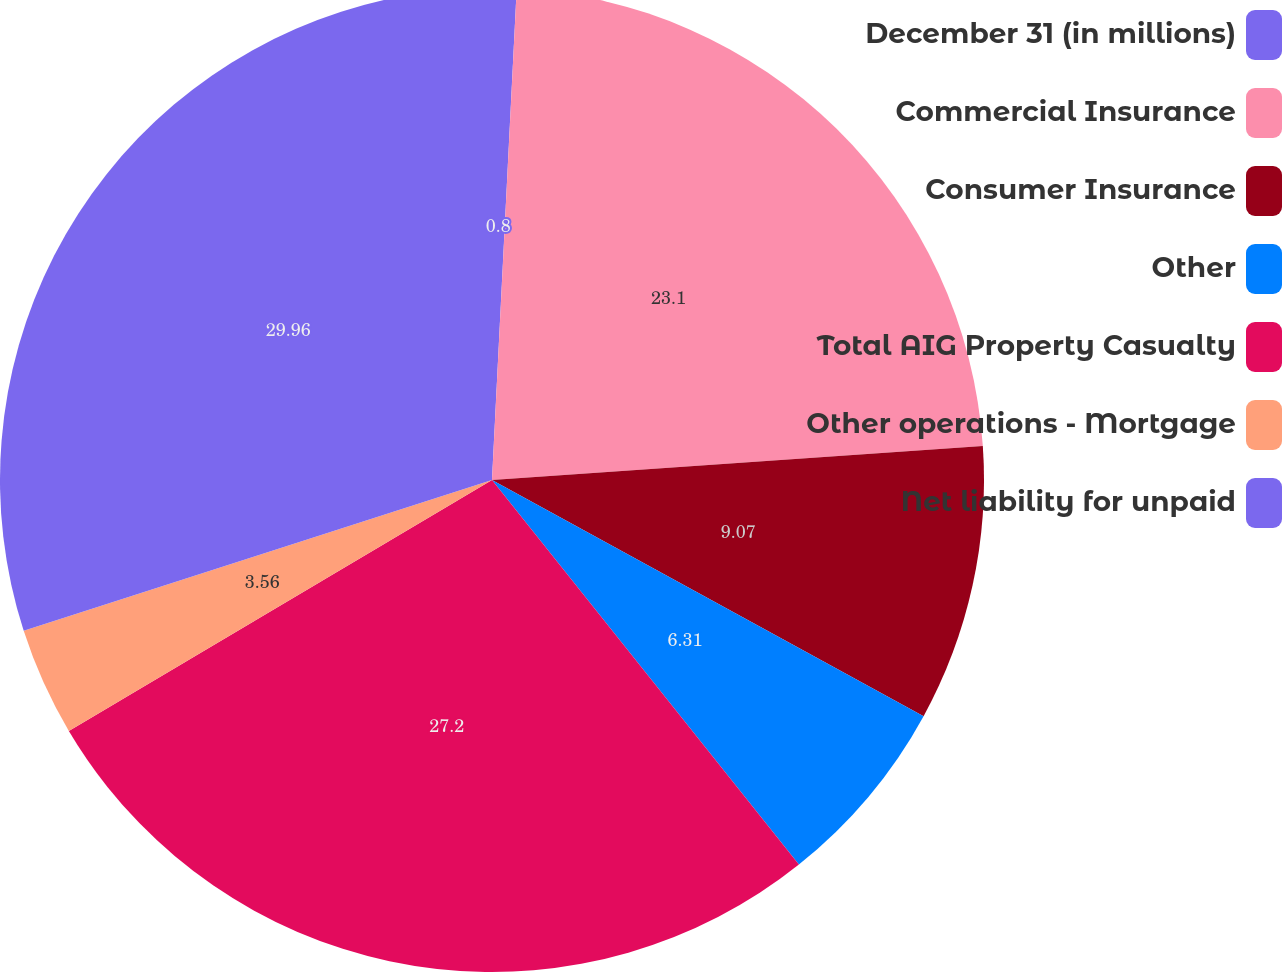Convert chart. <chart><loc_0><loc_0><loc_500><loc_500><pie_chart><fcel>December 31 (in millions)<fcel>Commercial Insurance<fcel>Consumer Insurance<fcel>Other<fcel>Total AIG Property Casualty<fcel>Other operations - Mortgage<fcel>Net liability for unpaid<nl><fcel>0.8%<fcel>23.1%<fcel>9.07%<fcel>6.31%<fcel>27.2%<fcel>3.56%<fcel>29.96%<nl></chart> 